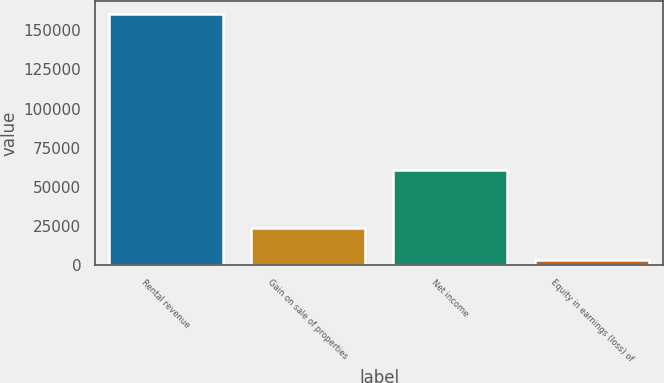<chart> <loc_0><loc_0><loc_500><loc_500><bar_chart><fcel>Rental revenue<fcel>Gain on sale of properties<fcel>Net income<fcel>Equity in earnings (loss) of<nl><fcel>160543<fcel>23696<fcel>60772<fcel>3304<nl></chart> 